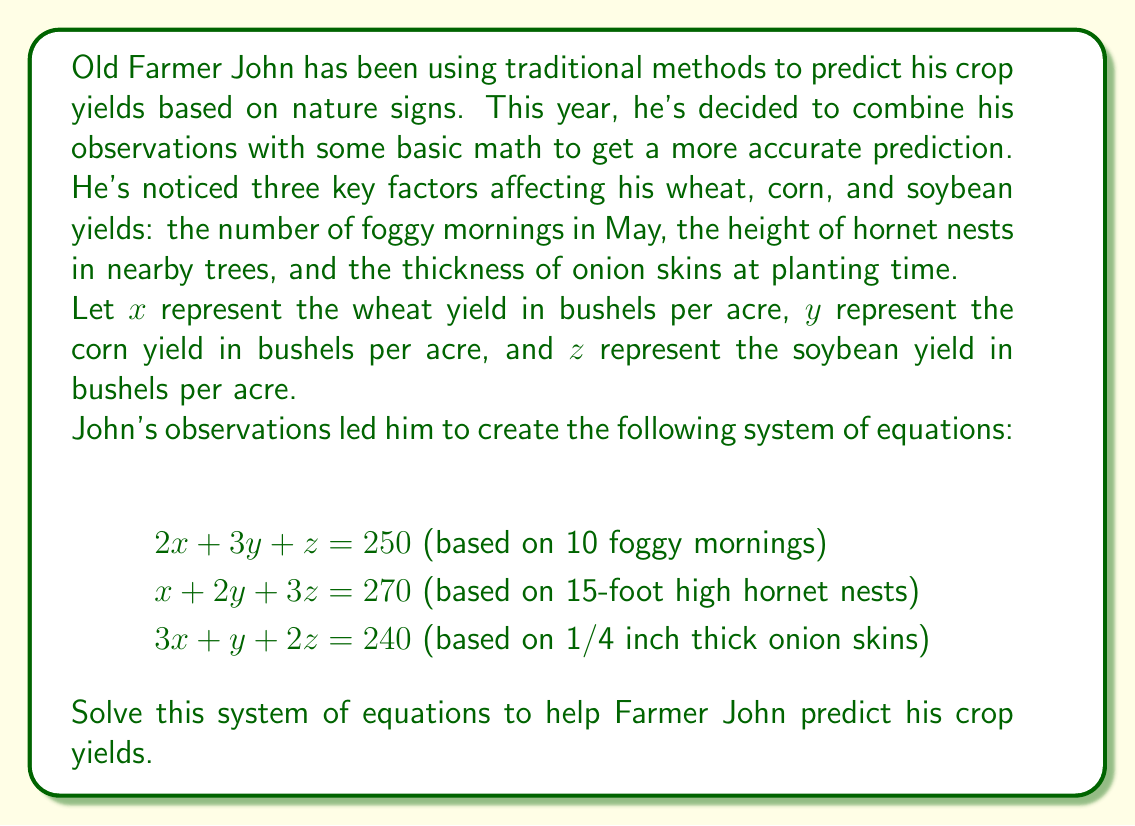Help me with this question. To solve this system of equations, we'll use the Gaussian elimination method:

1) First, let's write our augmented matrix:

$$\begin{bmatrix}
2 & 3 & 1 & 250 \\
1 & 2 & 3 & 270 \\
3 & 1 & 2 & 240
\end{bmatrix}$$

2) We'll use the first row as our pivot. Subtract 1/2 of the first row from the second row:

$$\begin{bmatrix}
2 & 3 & 1 & 250 \\
0 & 1/2 & 5/2 & 145 \\
3 & 1 & 2 & 240
\end{bmatrix}$$

3) Now subtract 3/2 of the first row from the third row:

$$\begin{bmatrix}
2 & 3 & 1 & 250 \\
0 & 1/2 & 5/2 & 145 \\
0 & -7/2 & 1/2 & -135
\end{bmatrix}$$

4) Multiply the second row by 2 to eliminate fractions:

$$\begin{bmatrix}
2 & 3 & 1 & 250 \\
0 & 1 & 5 & 290 \\
0 & -7/2 & 1/2 & -135
\end{bmatrix}$$

5) Add 7/2 of the second row to the third row:

$$\begin{bmatrix}
2 & 3 & 1 & 250 \\
0 & 1 & 5 & 290 \\
0 & 0 & 18 & 472.5
\end{bmatrix}$$

6) Now we have our system in row echelon form. We can solve for $z$:

$18z = 472.5$
$z = 26.25$

7) Substitute this value in the second equation:

$y + 5(26.25) = 290$
$y + 131.25 = 290$
$y = 158.75$

8) Finally, substitute these values in the first equation:

$2x + 3(158.75) + 26.25 = 250$
$2x + 476.25 + 26.25 = 250$
$2x = -252.5$
$x = -126.25$

Therefore, the solution is $x = -126.25$, $y = 158.75$, and $z = 26.25$.
Answer: Wheat yield (x): -126.25 bushels per acre
Corn yield (y): 158.75 bushels per acre
Soybean yield (z): 26.25 bushels per acre

Note: The negative wheat yield is not realistic and suggests that Farmer John might need to reconsider his traditional prediction methods or the reliability of his observations for wheat. 